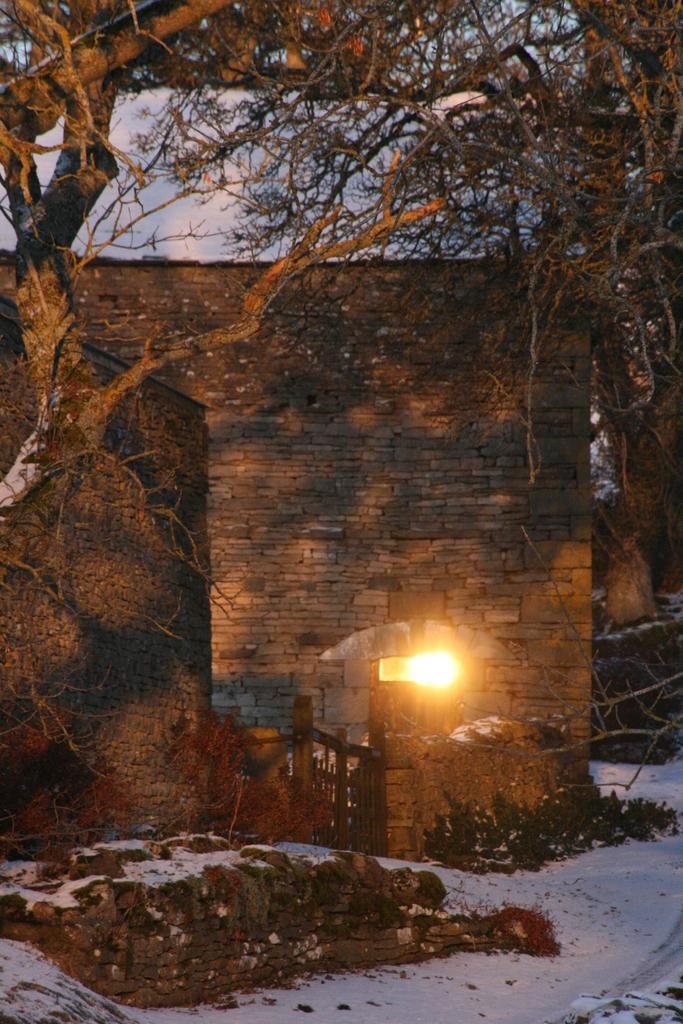How would you summarize this image in a sentence or two? In this image there are a few houses, in front of them there is a wooden gate and a light, there are trees, plants and snow on the surface. In the background there is the sky. 